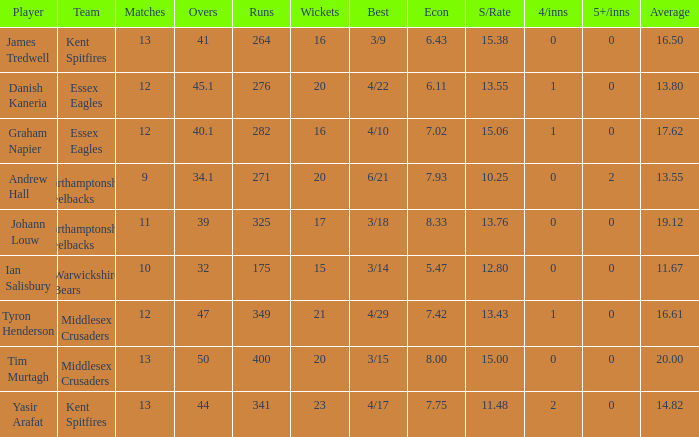Name the matches for wickets 17 11.0. 